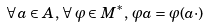<formula> <loc_0><loc_0><loc_500><loc_500>\forall \, a \in A , \, \forall \, \varphi \in M ^ { * } , \, \varphi a = \varphi ( a \cdot )</formula> 